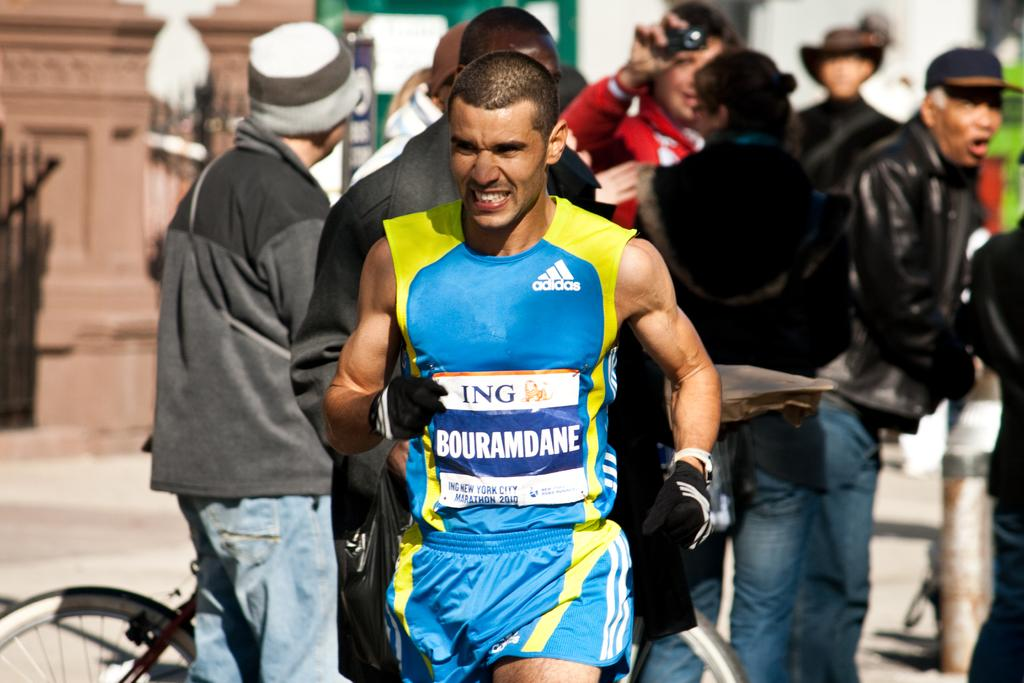Provide a one-sentence caption for the provided image. A runner wearing a blue and yellow Adidas shirt passes by a bicycle. 